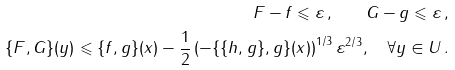<formula> <loc_0><loc_0><loc_500><loc_500>\| F - f \| \leqslant \varepsilon \, , \quad \| G - g \| \leqslant \varepsilon \, , \\ \{ F , G \} ( y ) \leqslant \{ f , g \} ( x ) - \frac { 1 } { 2 } \left ( - \{ \{ h , g \} , g \} ( x ) \right ) ^ { { 1 } / { 3 } } \varepsilon ^ { { 2 } / { 3 } } , \quad \forall y \in U \, .</formula> 